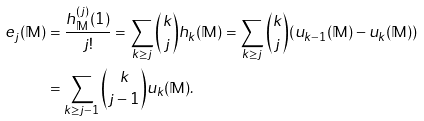<formula> <loc_0><loc_0><loc_500><loc_500>e _ { j } ( \mathbb { M } ) & = \frac { h _ { \mathbb { M } } ^ { ( j ) } ( 1 ) } { j ! } = \sum _ { k \geq j } \binom { k } { j } h _ { k } ( \mathbb { M } ) = \sum _ { k \geq j } \binom { k } { j } ( u _ { k - 1 } ( \mathbb { M } ) - u _ { k } ( \mathbb { M } ) ) \\ & = \sum _ { k \geq j - 1 } \binom { k } { j - 1 } u _ { k } ( \mathbb { M } ) . \\</formula> 